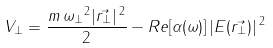Convert formula to latex. <formula><loc_0><loc_0><loc_500><loc_500>\ { V _ { \bot } } = { \frac { m { \, } { \omega { _ { \bot } } } ^ { 2 } | \vec { r _ { \bot } } | { \, } ^ { 2 } } { 2 } } - R e [ { \alpha ( \omega ) } ] { \, } { | { E } ( \vec { r _ { \bot } } ) | { \, } ^ { 2 } }</formula> 